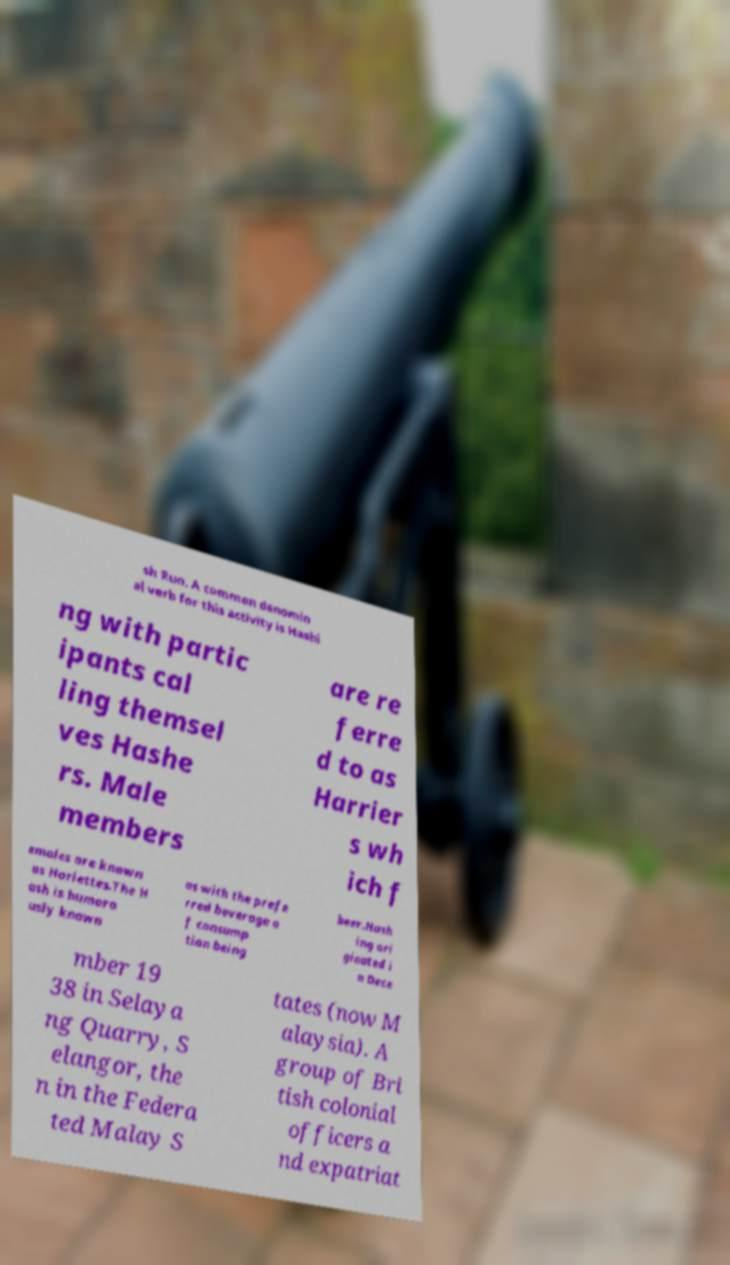Can you read and provide the text displayed in the image?This photo seems to have some interesting text. Can you extract and type it out for me? sh Run. A common denomin al verb for this activity is Hashi ng with partic ipants cal ling themsel ves Hashe rs. Male members are re ferre d to as Harrier s wh ich f emales are known as Hariettes.The H ash is humoro usly known as with the prefe rred beverage o f consump tion being beer.Hash ing ori ginated i n Dece mber 19 38 in Selaya ng Quarry, S elangor, the n in the Federa ted Malay S tates (now M alaysia). A group of Bri tish colonial officers a nd expatriat 